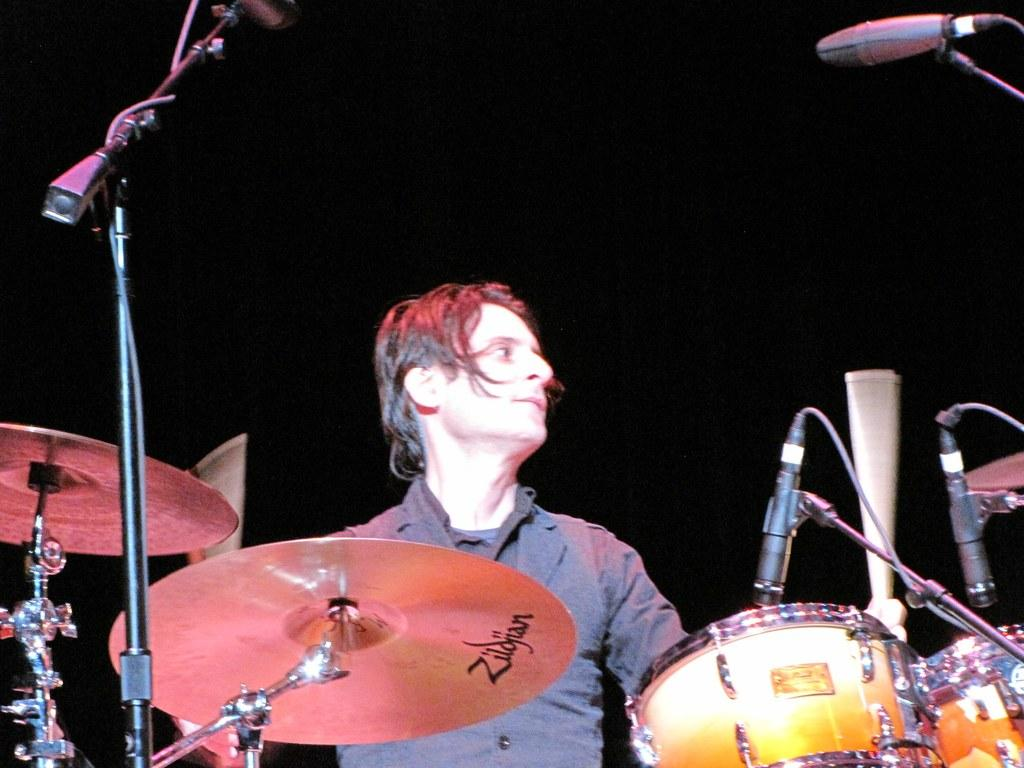What is the person in the image wearing? The person in the image is wearing a grey dress. What else can be seen in the image besides the person? Musical instruments and microphones are visible in the image. What is the color of the background in the image? The background of the image is black. Can you see a locket around the person's neck in the image? There is no mention of a locket in the provided facts, so it cannot be determined if one is present in the image. 